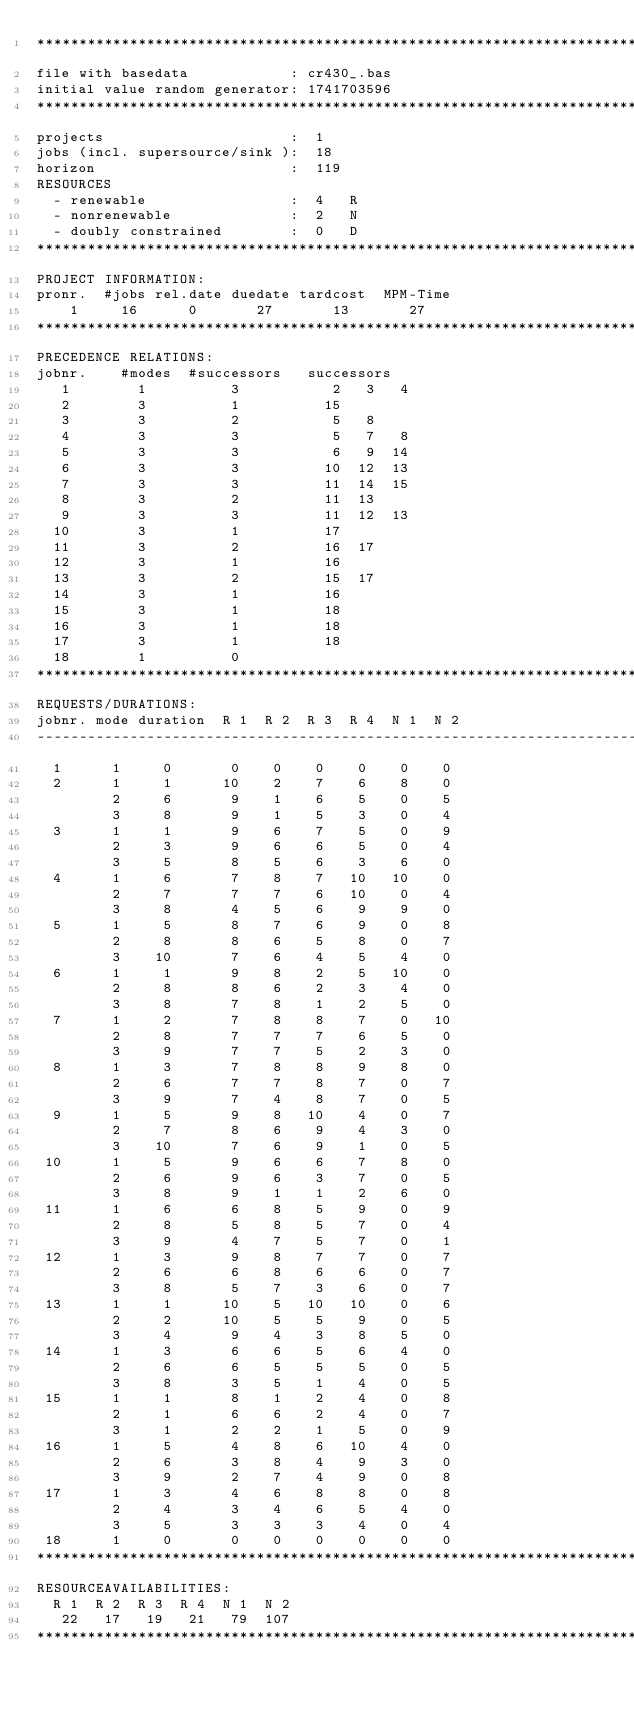<code> <loc_0><loc_0><loc_500><loc_500><_ObjectiveC_>************************************************************************
file with basedata            : cr430_.bas
initial value random generator: 1741703596
************************************************************************
projects                      :  1
jobs (incl. supersource/sink ):  18
horizon                       :  119
RESOURCES
  - renewable                 :  4   R
  - nonrenewable              :  2   N
  - doubly constrained        :  0   D
************************************************************************
PROJECT INFORMATION:
pronr.  #jobs rel.date duedate tardcost  MPM-Time
    1     16      0       27       13       27
************************************************************************
PRECEDENCE RELATIONS:
jobnr.    #modes  #successors   successors
   1        1          3           2   3   4
   2        3          1          15
   3        3          2           5   8
   4        3          3           5   7   8
   5        3          3           6   9  14
   6        3          3          10  12  13
   7        3          3          11  14  15
   8        3          2          11  13
   9        3          3          11  12  13
  10        3          1          17
  11        3          2          16  17
  12        3          1          16
  13        3          2          15  17
  14        3          1          16
  15        3          1          18
  16        3          1          18
  17        3          1          18
  18        1          0        
************************************************************************
REQUESTS/DURATIONS:
jobnr. mode duration  R 1  R 2  R 3  R 4  N 1  N 2
------------------------------------------------------------------------
  1      1     0       0    0    0    0    0    0
  2      1     1      10    2    7    6    8    0
         2     6       9    1    6    5    0    5
         3     8       9    1    5    3    0    4
  3      1     1       9    6    7    5    0    9
         2     3       9    6    6    5    0    4
         3     5       8    5    6    3    6    0
  4      1     6       7    8    7   10   10    0
         2     7       7    7    6   10    0    4
         3     8       4    5    6    9    9    0
  5      1     5       8    7    6    9    0    8
         2     8       8    6    5    8    0    7
         3    10       7    6    4    5    4    0
  6      1     1       9    8    2    5   10    0
         2     8       8    6    2    3    4    0
         3     8       7    8    1    2    5    0
  7      1     2       7    8    8    7    0   10
         2     8       7    7    7    6    5    0
         3     9       7    7    5    2    3    0
  8      1     3       7    8    8    9    8    0
         2     6       7    7    8    7    0    7
         3     9       7    4    8    7    0    5
  9      1     5       9    8   10    4    0    7
         2     7       8    6    9    4    3    0
         3    10       7    6    9    1    0    5
 10      1     5       9    6    6    7    8    0
         2     6       9    6    3    7    0    5
         3     8       9    1    1    2    6    0
 11      1     6       6    8    5    9    0    9
         2     8       5    8    5    7    0    4
         3     9       4    7    5    7    0    1
 12      1     3       9    8    7    7    0    7
         2     6       6    8    6    6    0    7
         3     8       5    7    3    6    0    7
 13      1     1      10    5   10   10    0    6
         2     2      10    5    5    9    0    5
         3     4       9    4    3    8    5    0
 14      1     3       6    6    5    6    4    0
         2     6       6    5    5    5    0    5
         3     8       3    5    1    4    0    5
 15      1     1       8    1    2    4    0    8
         2     1       6    6    2    4    0    7
         3     1       2    2    1    5    0    9
 16      1     5       4    8    6   10    4    0
         2     6       3    8    4    9    3    0
         3     9       2    7    4    9    0    8
 17      1     3       4    6    8    8    0    8
         2     4       3    4    6    5    4    0
         3     5       3    3    3    4    0    4
 18      1     0       0    0    0    0    0    0
************************************************************************
RESOURCEAVAILABILITIES:
  R 1  R 2  R 3  R 4  N 1  N 2
   22   17   19   21   79  107
************************************************************************
</code> 